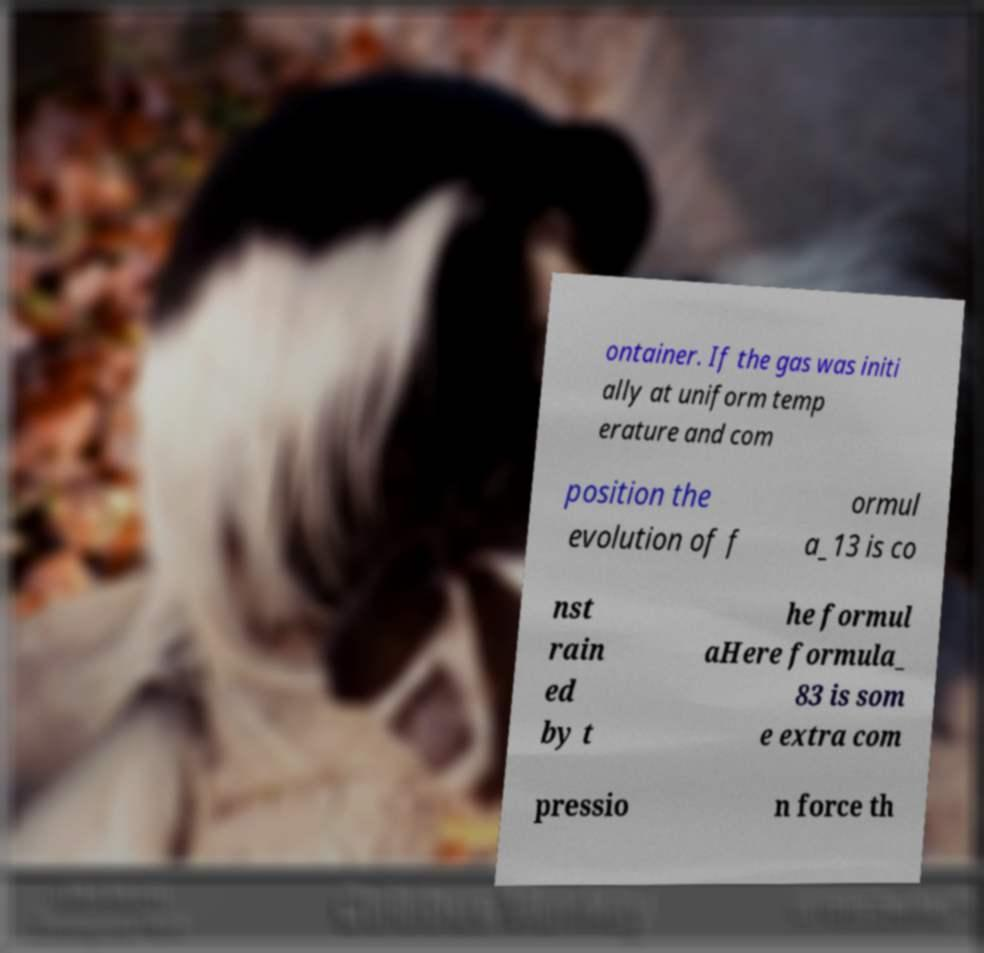Could you assist in decoding the text presented in this image and type it out clearly? ontainer. If the gas was initi ally at uniform temp erature and com position the evolution of f ormul a_13 is co nst rain ed by t he formul aHere formula_ 83 is som e extra com pressio n force th 